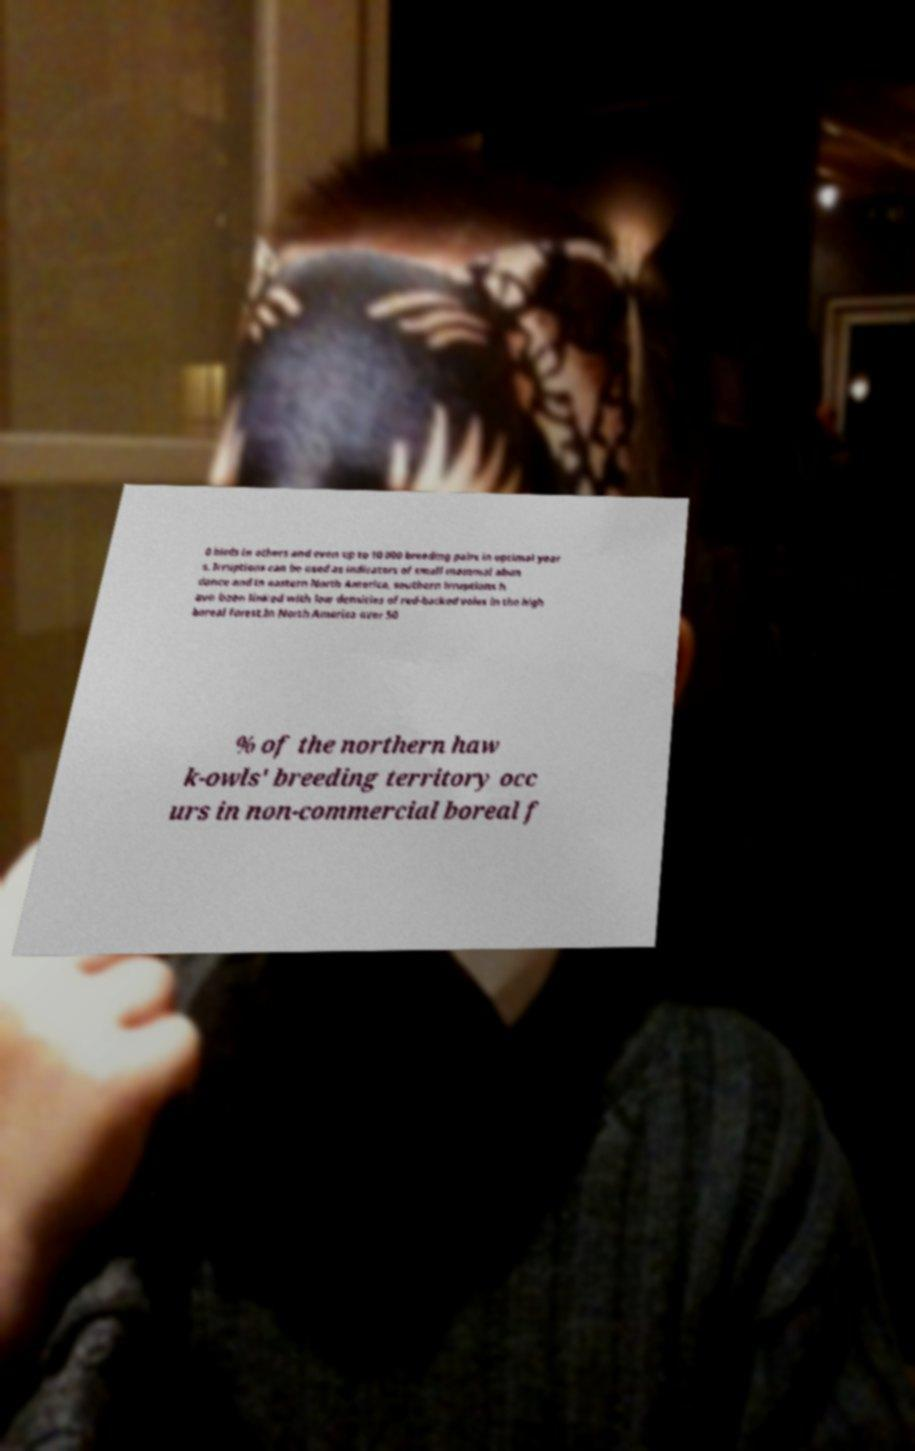Can you read and provide the text displayed in the image?This photo seems to have some interesting text. Can you extract and type it out for me? 0 birds in others and even up to 10 000 breeding pairs in optimal year s. Irruptions can be used as indicators of small mammal abun dance and in eastern North America, southern irruptions h ave been linked with low densities of red-backed voles in the high boreal forest.In North America over 50 % of the northern haw k-owls' breeding territory occ urs in non-commercial boreal f 